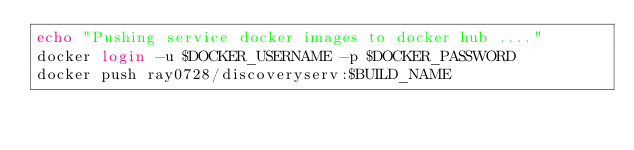<code> <loc_0><loc_0><loc_500><loc_500><_Bash_>echo "Pushing service docker images to docker hub ...."
docker login -u $DOCKER_USERNAME -p $DOCKER_PASSWORD
docker push ray0728/discoveryserv:$BUILD_NAME
</code> 